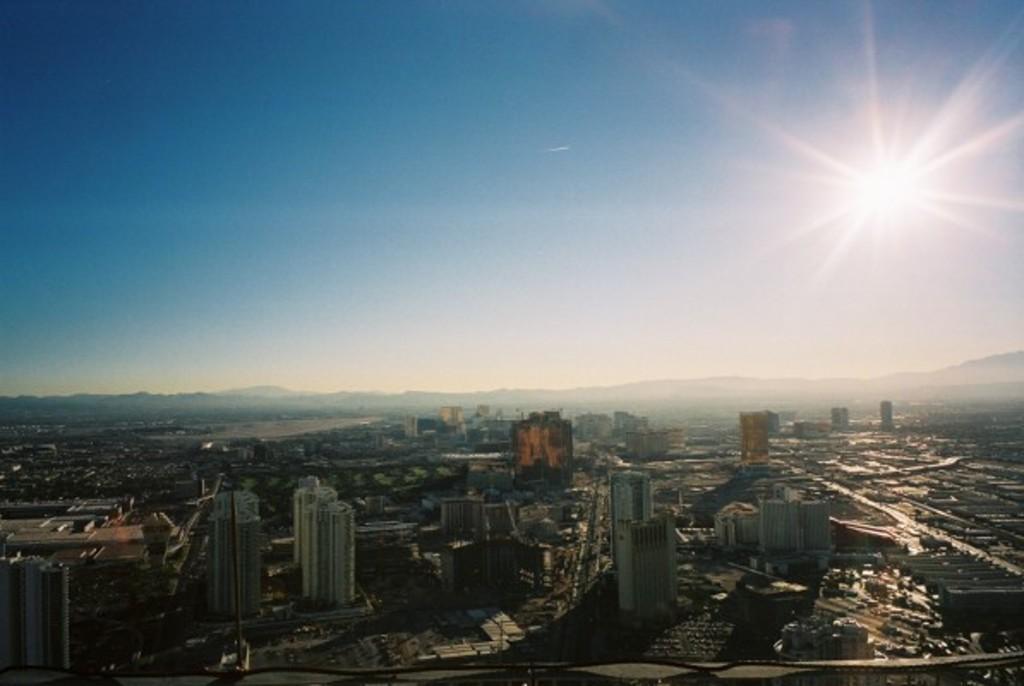Can you describe this image briefly? In front of the image there are buildings. In the background of the image there are mountains. At the top of the image there is sun in the sky. 